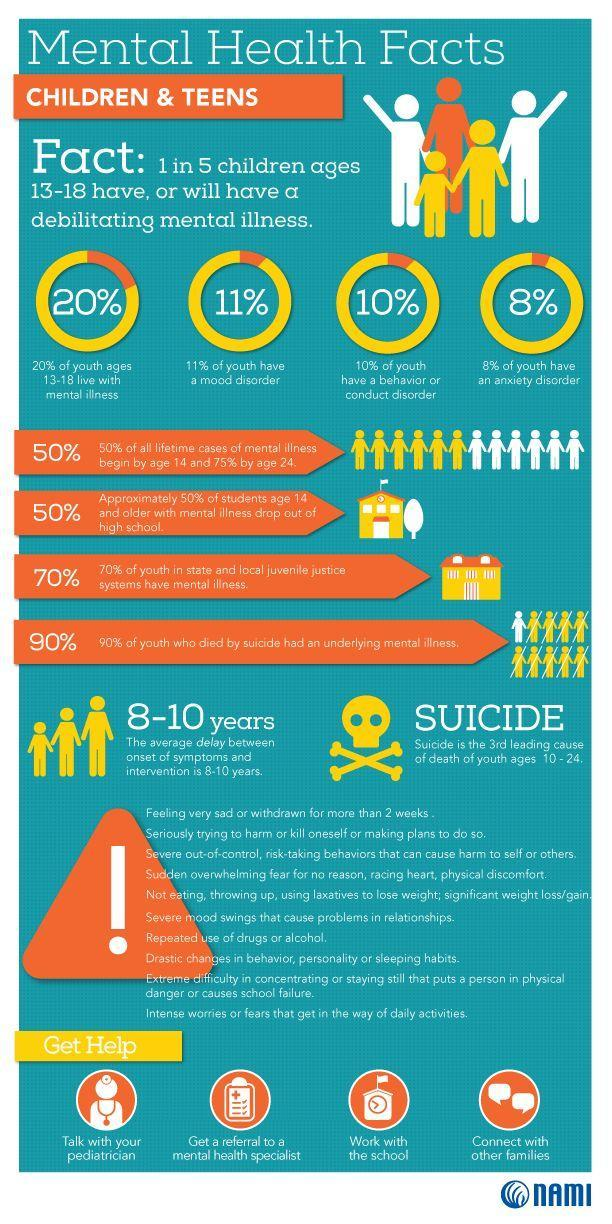What percentage of youth do not have a problem of conduct disorder?
Answer the question with a short phrase. 90% What percentage of youth have a problem of mood disorder? 11% What percentage of youth have a problem of anxiety disorder? 8% What is the average delay between onset of symptoms and intervention in mental illness? 8-10 years 